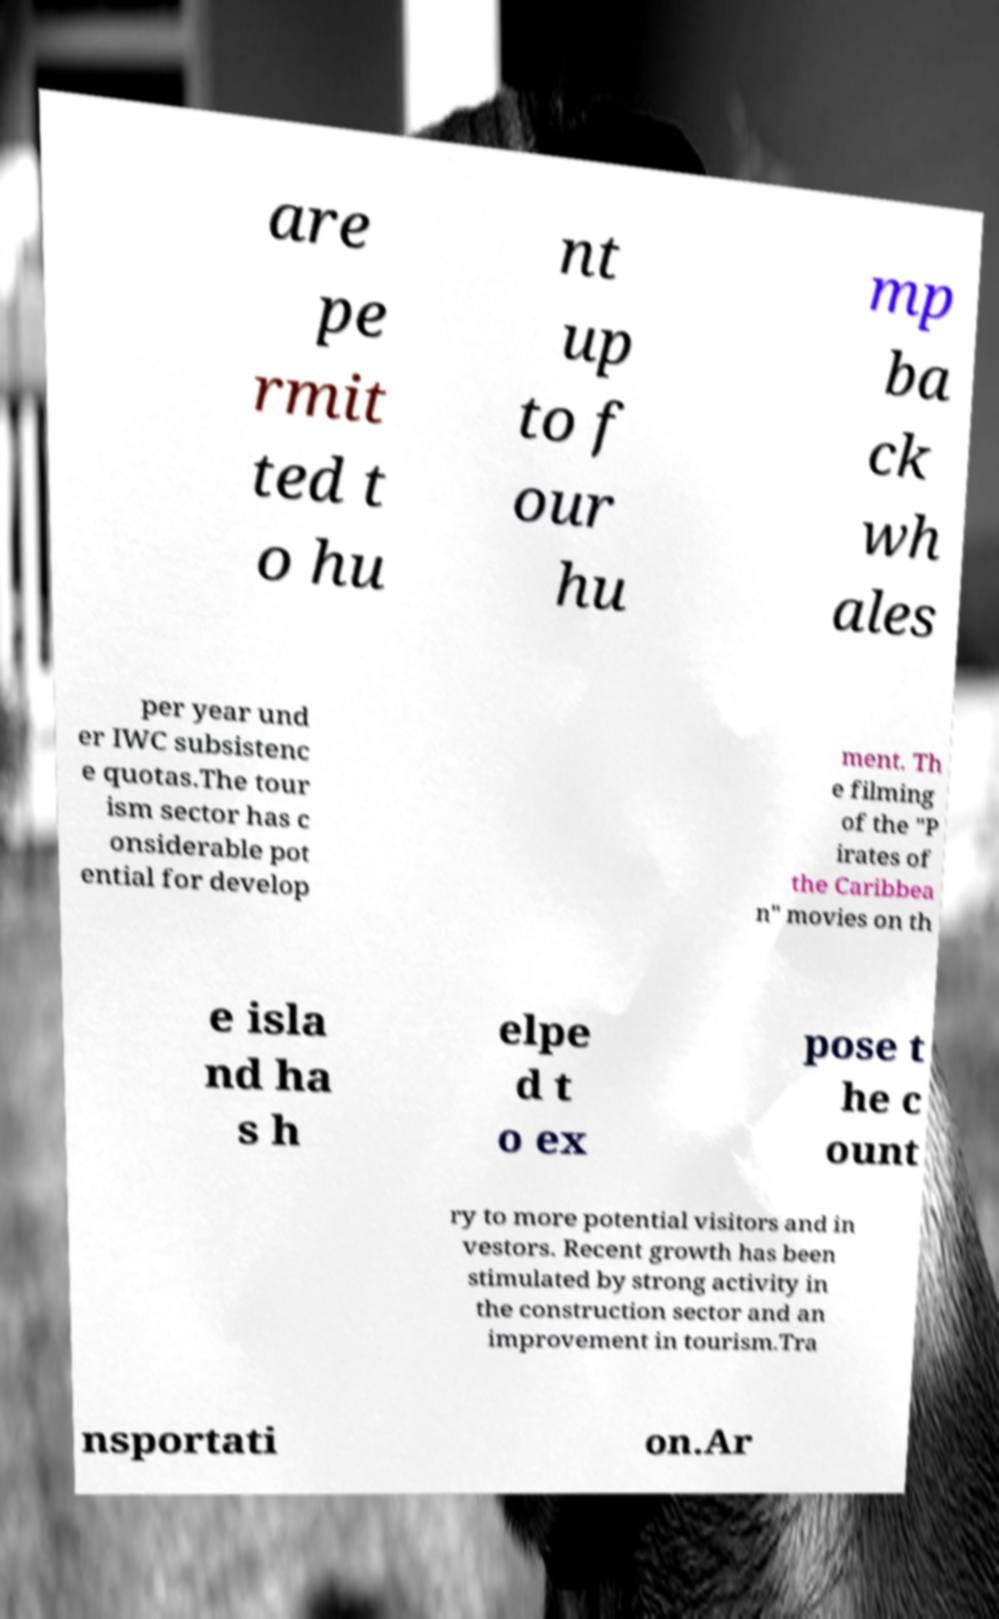Could you assist in decoding the text presented in this image and type it out clearly? are pe rmit ted t o hu nt up to f our hu mp ba ck wh ales per year und er IWC subsistenc e quotas.The tour ism sector has c onsiderable pot ential for develop ment. Th e filming of the "P irates of the Caribbea n" movies on th e isla nd ha s h elpe d t o ex pose t he c ount ry to more potential visitors and in vestors. Recent growth has been stimulated by strong activity in the construction sector and an improvement in tourism.Tra nsportati on.Ar 